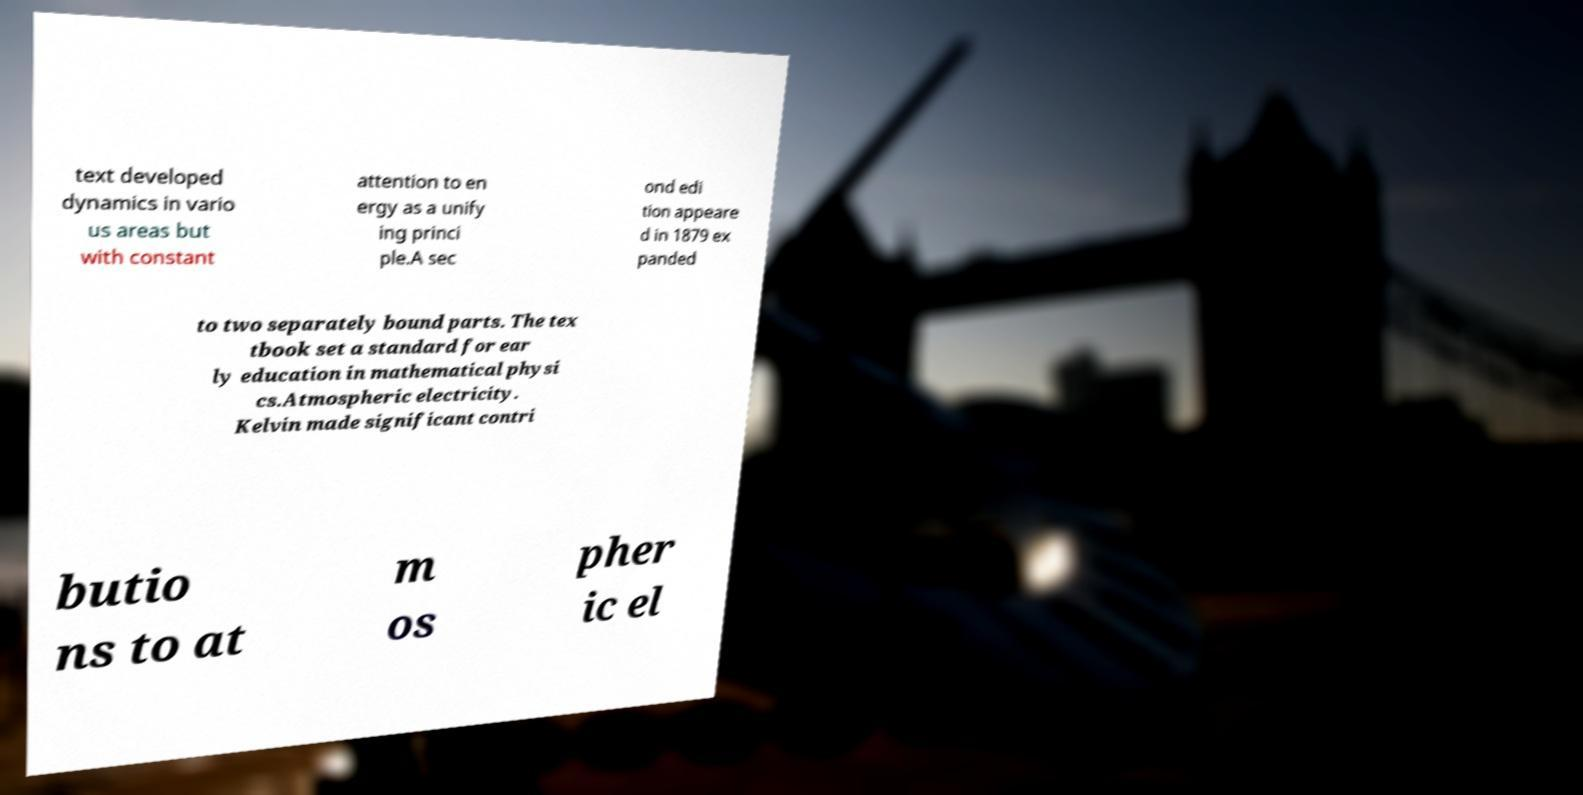There's text embedded in this image that I need extracted. Can you transcribe it verbatim? text developed dynamics in vario us areas but with constant attention to en ergy as a unify ing princi ple.A sec ond edi tion appeare d in 1879 ex panded to two separately bound parts. The tex tbook set a standard for ear ly education in mathematical physi cs.Atmospheric electricity. Kelvin made significant contri butio ns to at m os pher ic el 